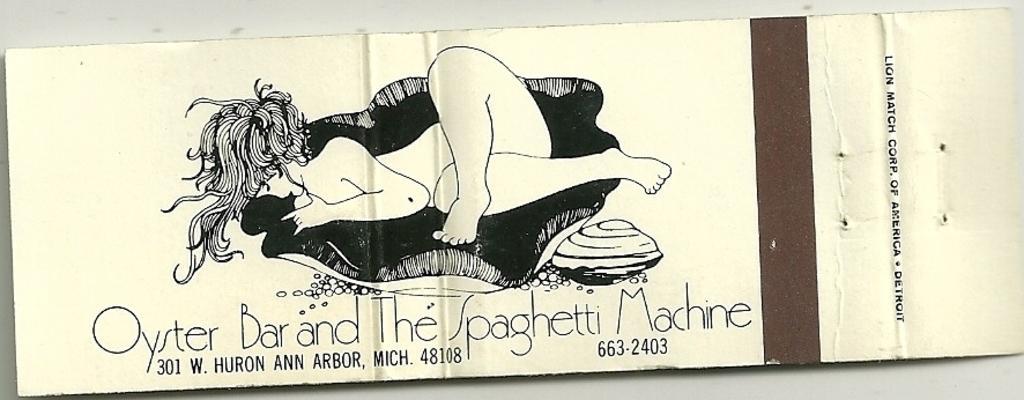How would you summarize this image in a sentence or two? In this image I can see some text and a drawing of person on the poster. 